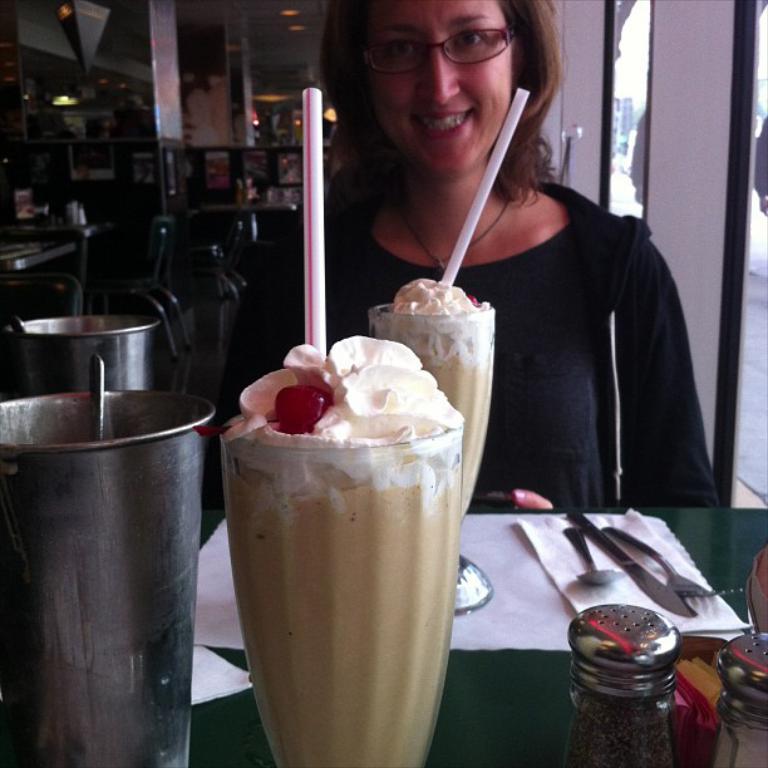Can you describe this image briefly? In this image we can see a woman is sitting, and smiling, in front here is the table, and glasses on it, here is the cream, here is some liquid in it, here is the straw, here are the spoons, and some objects on it, here is the light. 